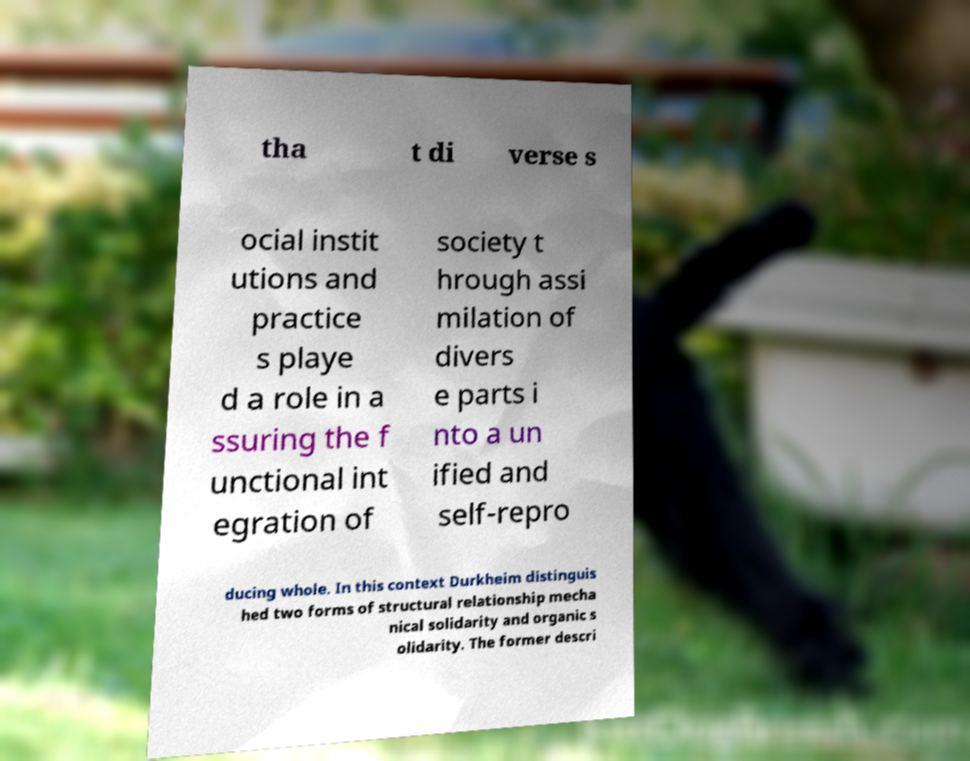Could you assist in decoding the text presented in this image and type it out clearly? tha t di verse s ocial instit utions and practice s playe d a role in a ssuring the f unctional int egration of society t hrough assi milation of divers e parts i nto a un ified and self-repro ducing whole. In this context Durkheim distinguis hed two forms of structural relationship mecha nical solidarity and organic s olidarity. The former descri 